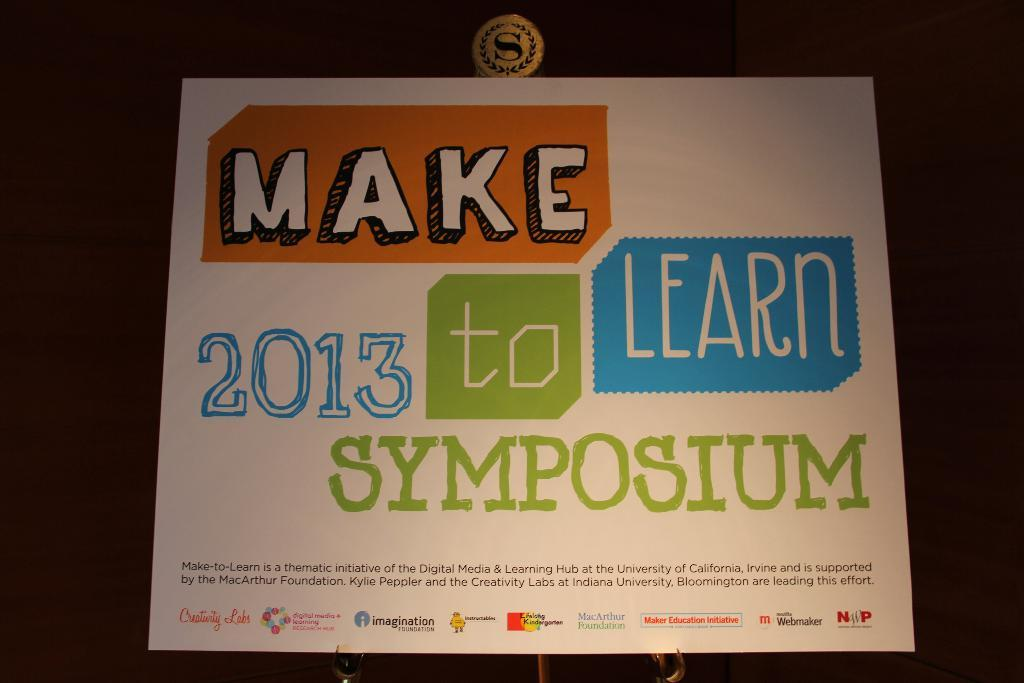Provide a one-sentence caption for the provided image. Make 2013 to learn Symposium paper from the University of California. 